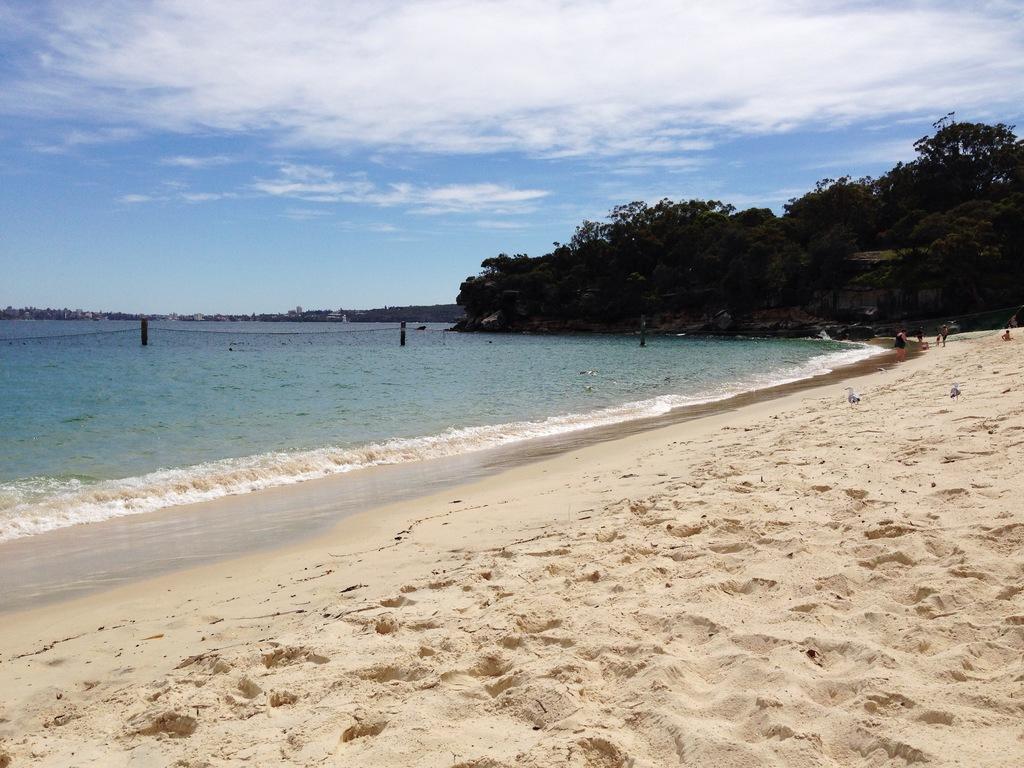Can you describe this image briefly? In the picture I can see sand, water, trees and the blue color sky with clouds in the background. 